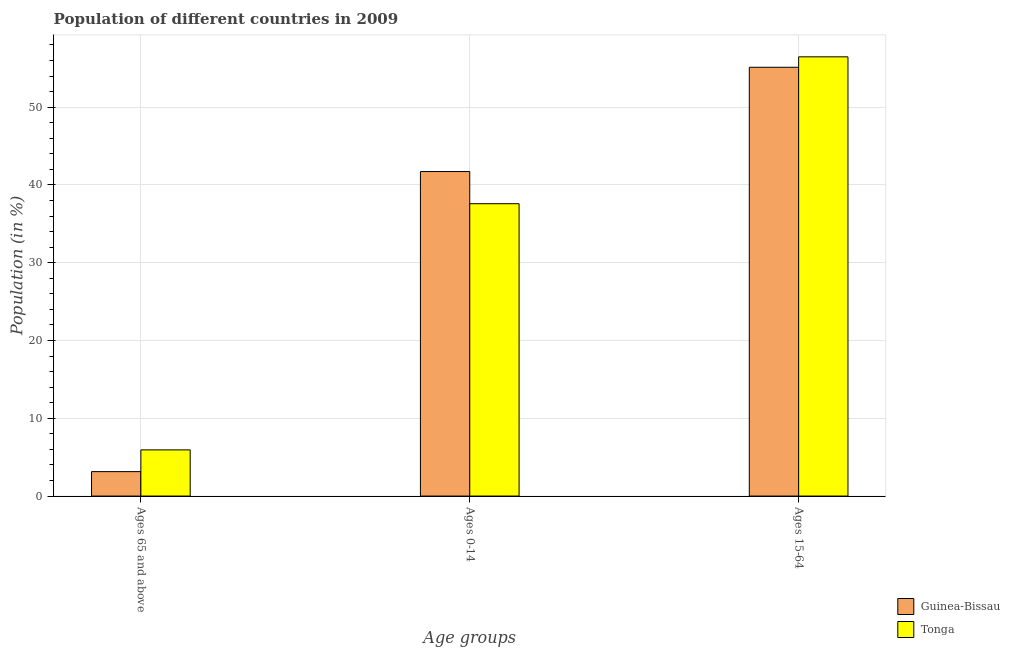How many groups of bars are there?
Your answer should be compact. 3. What is the label of the 2nd group of bars from the left?
Ensure brevity in your answer.  Ages 0-14. What is the percentage of population within the age-group 15-64 in Guinea-Bissau?
Offer a very short reply. 55.13. Across all countries, what is the maximum percentage of population within the age-group 0-14?
Keep it short and to the point. 41.73. Across all countries, what is the minimum percentage of population within the age-group 0-14?
Provide a short and direct response. 37.59. In which country was the percentage of population within the age-group of 65 and above maximum?
Provide a succinct answer. Tonga. In which country was the percentage of population within the age-group 0-14 minimum?
Your answer should be compact. Tonga. What is the total percentage of population within the age-group 0-14 in the graph?
Provide a short and direct response. 79.31. What is the difference between the percentage of population within the age-group 15-64 in Guinea-Bissau and that in Tonga?
Offer a very short reply. -1.34. What is the difference between the percentage of population within the age-group 15-64 in Guinea-Bissau and the percentage of population within the age-group of 65 and above in Tonga?
Make the answer very short. 49.2. What is the average percentage of population within the age-group 15-64 per country?
Offer a terse response. 55.8. What is the difference between the percentage of population within the age-group 0-14 and percentage of population within the age-group 15-64 in Guinea-Bissau?
Offer a terse response. -13.41. What is the ratio of the percentage of population within the age-group 0-14 in Tonga to that in Guinea-Bissau?
Offer a terse response. 0.9. Is the percentage of population within the age-group 0-14 in Guinea-Bissau less than that in Tonga?
Offer a terse response. No. Is the difference between the percentage of population within the age-group 15-64 in Tonga and Guinea-Bissau greater than the difference between the percentage of population within the age-group of 65 and above in Tonga and Guinea-Bissau?
Provide a succinct answer. No. What is the difference between the highest and the second highest percentage of population within the age-group of 65 and above?
Your answer should be very brief. 2.79. What is the difference between the highest and the lowest percentage of population within the age-group 15-64?
Keep it short and to the point. 1.34. What does the 1st bar from the left in Ages 0-14 represents?
Provide a succinct answer. Guinea-Bissau. What does the 2nd bar from the right in Ages 65 and above represents?
Your answer should be very brief. Guinea-Bissau. Are all the bars in the graph horizontal?
Ensure brevity in your answer.  No. How many countries are there in the graph?
Ensure brevity in your answer.  2. What is the difference between two consecutive major ticks on the Y-axis?
Offer a terse response. 10. Are the values on the major ticks of Y-axis written in scientific E-notation?
Give a very brief answer. No. Does the graph contain grids?
Keep it short and to the point. Yes. How many legend labels are there?
Give a very brief answer. 2. What is the title of the graph?
Your answer should be compact. Population of different countries in 2009. Does "Somalia" appear as one of the legend labels in the graph?
Give a very brief answer. No. What is the label or title of the X-axis?
Ensure brevity in your answer.  Age groups. What is the label or title of the Y-axis?
Your answer should be compact. Population (in %). What is the Population (in %) of Guinea-Bissau in Ages 65 and above?
Offer a very short reply. 3.14. What is the Population (in %) of Tonga in Ages 65 and above?
Your answer should be very brief. 5.94. What is the Population (in %) of Guinea-Bissau in Ages 0-14?
Offer a terse response. 41.73. What is the Population (in %) in Tonga in Ages 0-14?
Give a very brief answer. 37.59. What is the Population (in %) in Guinea-Bissau in Ages 15-64?
Your answer should be compact. 55.13. What is the Population (in %) of Tonga in Ages 15-64?
Keep it short and to the point. 56.47. Across all Age groups, what is the maximum Population (in %) in Guinea-Bissau?
Ensure brevity in your answer.  55.13. Across all Age groups, what is the maximum Population (in %) in Tonga?
Offer a terse response. 56.47. Across all Age groups, what is the minimum Population (in %) of Guinea-Bissau?
Provide a short and direct response. 3.14. Across all Age groups, what is the minimum Population (in %) of Tonga?
Offer a very short reply. 5.94. What is the difference between the Population (in %) of Guinea-Bissau in Ages 65 and above and that in Ages 0-14?
Make the answer very short. -38.58. What is the difference between the Population (in %) of Tonga in Ages 65 and above and that in Ages 0-14?
Provide a short and direct response. -31.65. What is the difference between the Population (in %) in Guinea-Bissau in Ages 65 and above and that in Ages 15-64?
Provide a succinct answer. -51.99. What is the difference between the Population (in %) of Tonga in Ages 65 and above and that in Ages 15-64?
Give a very brief answer. -50.54. What is the difference between the Population (in %) in Guinea-Bissau in Ages 0-14 and that in Ages 15-64?
Your answer should be compact. -13.41. What is the difference between the Population (in %) of Tonga in Ages 0-14 and that in Ages 15-64?
Keep it short and to the point. -18.88. What is the difference between the Population (in %) of Guinea-Bissau in Ages 65 and above and the Population (in %) of Tonga in Ages 0-14?
Your response must be concise. -34.45. What is the difference between the Population (in %) in Guinea-Bissau in Ages 65 and above and the Population (in %) in Tonga in Ages 15-64?
Your answer should be compact. -53.33. What is the difference between the Population (in %) in Guinea-Bissau in Ages 0-14 and the Population (in %) in Tonga in Ages 15-64?
Offer a terse response. -14.75. What is the average Population (in %) in Guinea-Bissau per Age groups?
Your answer should be compact. 33.33. What is the average Population (in %) in Tonga per Age groups?
Your answer should be very brief. 33.33. What is the difference between the Population (in %) in Guinea-Bissau and Population (in %) in Tonga in Ages 65 and above?
Give a very brief answer. -2.79. What is the difference between the Population (in %) of Guinea-Bissau and Population (in %) of Tonga in Ages 0-14?
Offer a terse response. 4.14. What is the difference between the Population (in %) in Guinea-Bissau and Population (in %) in Tonga in Ages 15-64?
Offer a terse response. -1.34. What is the ratio of the Population (in %) in Guinea-Bissau in Ages 65 and above to that in Ages 0-14?
Offer a very short reply. 0.08. What is the ratio of the Population (in %) in Tonga in Ages 65 and above to that in Ages 0-14?
Keep it short and to the point. 0.16. What is the ratio of the Population (in %) in Guinea-Bissau in Ages 65 and above to that in Ages 15-64?
Provide a succinct answer. 0.06. What is the ratio of the Population (in %) in Tonga in Ages 65 and above to that in Ages 15-64?
Offer a terse response. 0.11. What is the ratio of the Population (in %) in Guinea-Bissau in Ages 0-14 to that in Ages 15-64?
Give a very brief answer. 0.76. What is the ratio of the Population (in %) of Tonga in Ages 0-14 to that in Ages 15-64?
Your response must be concise. 0.67. What is the difference between the highest and the second highest Population (in %) in Guinea-Bissau?
Keep it short and to the point. 13.41. What is the difference between the highest and the second highest Population (in %) of Tonga?
Your response must be concise. 18.88. What is the difference between the highest and the lowest Population (in %) in Guinea-Bissau?
Ensure brevity in your answer.  51.99. What is the difference between the highest and the lowest Population (in %) of Tonga?
Give a very brief answer. 50.54. 